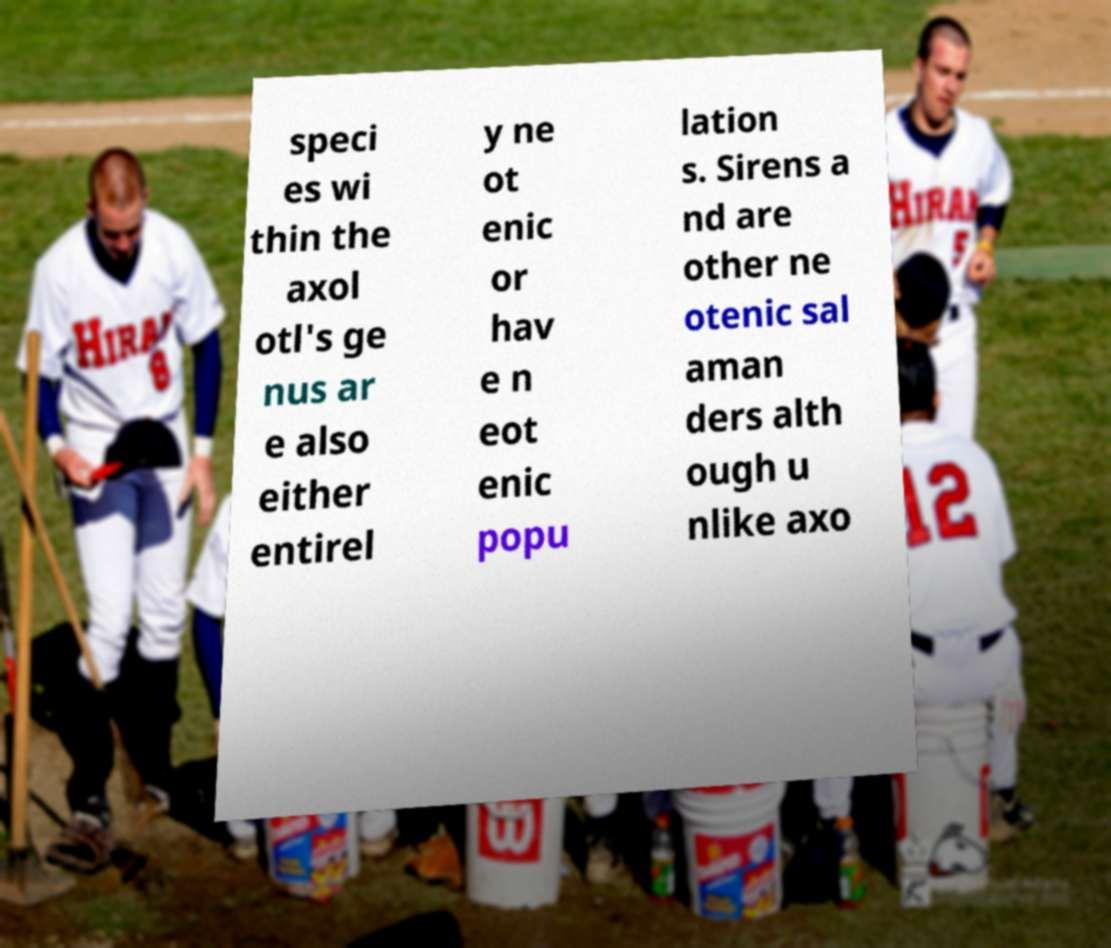Could you assist in decoding the text presented in this image and type it out clearly? speci es wi thin the axol otl's ge nus ar e also either entirel y ne ot enic or hav e n eot enic popu lation s. Sirens a nd are other ne otenic sal aman ders alth ough u nlike axo 